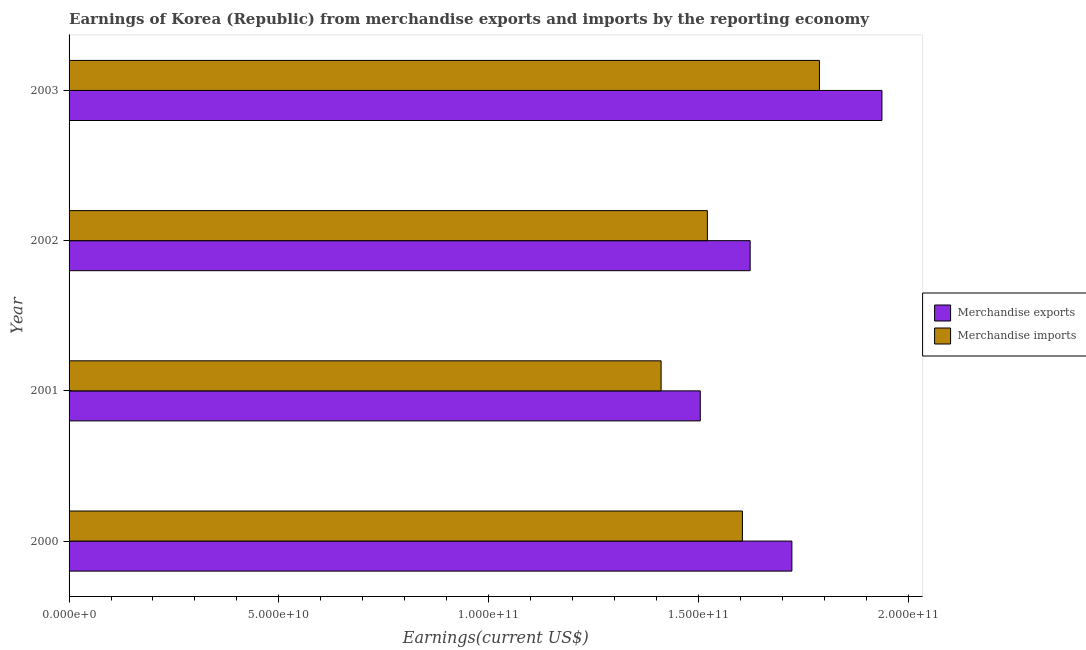How many groups of bars are there?
Offer a terse response. 4. Are the number of bars per tick equal to the number of legend labels?
Your answer should be compact. Yes. Are the number of bars on each tick of the Y-axis equal?
Your response must be concise. Yes. What is the earnings from merchandise imports in 2000?
Provide a succinct answer. 1.60e+11. Across all years, what is the maximum earnings from merchandise exports?
Give a very brief answer. 1.94e+11. Across all years, what is the minimum earnings from merchandise exports?
Your answer should be very brief. 1.50e+11. In which year was the earnings from merchandise imports maximum?
Offer a very short reply. 2003. What is the total earnings from merchandise imports in the graph?
Your answer should be compact. 6.33e+11. What is the difference between the earnings from merchandise imports in 2001 and that in 2003?
Keep it short and to the point. -3.77e+1. What is the difference between the earnings from merchandise exports in 2002 and the earnings from merchandise imports in 2001?
Offer a very short reply. 2.12e+1. What is the average earnings from merchandise exports per year?
Ensure brevity in your answer.  1.70e+11. In the year 2001, what is the difference between the earnings from merchandise imports and earnings from merchandise exports?
Ensure brevity in your answer.  -9.34e+09. What is the ratio of the earnings from merchandise exports in 2000 to that in 2001?
Provide a short and direct response. 1.15. What is the difference between the highest and the second highest earnings from merchandise exports?
Your answer should be very brief. 2.15e+1. What is the difference between the highest and the lowest earnings from merchandise imports?
Ensure brevity in your answer.  3.77e+1. In how many years, is the earnings from merchandise imports greater than the average earnings from merchandise imports taken over all years?
Give a very brief answer. 2. What does the 1st bar from the top in 2002 represents?
Offer a terse response. Merchandise imports. What does the 2nd bar from the bottom in 2002 represents?
Keep it short and to the point. Merchandise imports. Are all the bars in the graph horizontal?
Your answer should be compact. Yes. What is the difference between two consecutive major ticks on the X-axis?
Offer a terse response. 5.00e+1. Does the graph contain any zero values?
Keep it short and to the point. No. Does the graph contain grids?
Offer a very short reply. No. How are the legend labels stacked?
Ensure brevity in your answer.  Vertical. What is the title of the graph?
Make the answer very short. Earnings of Korea (Republic) from merchandise exports and imports by the reporting economy. Does "Secondary Education" appear as one of the legend labels in the graph?
Keep it short and to the point. No. What is the label or title of the X-axis?
Provide a succinct answer. Earnings(current US$). What is the Earnings(current US$) of Merchandise exports in 2000?
Keep it short and to the point. 1.72e+11. What is the Earnings(current US$) in Merchandise imports in 2000?
Give a very brief answer. 1.60e+11. What is the Earnings(current US$) of Merchandise exports in 2001?
Make the answer very short. 1.50e+11. What is the Earnings(current US$) in Merchandise imports in 2001?
Offer a very short reply. 1.41e+11. What is the Earnings(current US$) of Merchandise exports in 2002?
Your answer should be very brief. 1.62e+11. What is the Earnings(current US$) of Merchandise imports in 2002?
Your answer should be compact. 1.52e+11. What is the Earnings(current US$) in Merchandise exports in 2003?
Offer a very short reply. 1.94e+11. What is the Earnings(current US$) of Merchandise imports in 2003?
Provide a succinct answer. 1.79e+11. Across all years, what is the maximum Earnings(current US$) in Merchandise exports?
Keep it short and to the point. 1.94e+11. Across all years, what is the maximum Earnings(current US$) in Merchandise imports?
Provide a succinct answer. 1.79e+11. Across all years, what is the minimum Earnings(current US$) of Merchandise exports?
Your answer should be compact. 1.50e+11. Across all years, what is the minimum Earnings(current US$) in Merchandise imports?
Make the answer very short. 1.41e+11. What is the total Earnings(current US$) in Merchandise exports in the graph?
Your answer should be very brief. 6.79e+11. What is the total Earnings(current US$) of Merchandise imports in the graph?
Provide a short and direct response. 6.33e+11. What is the difference between the Earnings(current US$) in Merchandise exports in 2000 and that in 2001?
Your answer should be compact. 2.18e+1. What is the difference between the Earnings(current US$) of Merchandise imports in 2000 and that in 2001?
Provide a short and direct response. 1.94e+1. What is the difference between the Earnings(current US$) in Merchandise exports in 2000 and that in 2002?
Make the answer very short. 9.95e+09. What is the difference between the Earnings(current US$) of Merchandise imports in 2000 and that in 2002?
Offer a very short reply. 8.36e+09. What is the difference between the Earnings(current US$) in Merchandise exports in 2000 and that in 2003?
Make the answer very short. -2.15e+1. What is the difference between the Earnings(current US$) of Merchandise imports in 2000 and that in 2003?
Provide a short and direct response. -1.83e+1. What is the difference between the Earnings(current US$) of Merchandise exports in 2001 and that in 2002?
Your response must be concise. -1.19e+1. What is the difference between the Earnings(current US$) of Merchandise imports in 2001 and that in 2002?
Ensure brevity in your answer.  -1.10e+1. What is the difference between the Earnings(current US$) of Merchandise exports in 2001 and that in 2003?
Offer a very short reply. -4.33e+1. What is the difference between the Earnings(current US$) of Merchandise imports in 2001 and that in 2003?
Your answer should be compact. -3.77e+1. What is the difference between the Earnings(current US$) of Merchandise exports in 2002 and that in 2003?
Give a very brief answer. -3.14e+1. What is the difference between the Earnings(current US$) of Merchandise imports in 2002 and that in 2003?
Provide a succinct answer. -2.67e+1. What is the difference between the Earnings(current US$) of Merchandise exports in 2000 and the Earnings(current US$) of Merchandise imports in 2001?
Provide a short and direct response. 3.12e+1. What is the difference between the Earnings(current US$) of Merchandise exports in 2000 and the Earnings(current US$) of Merchandise imports in 2002?
Offer a terse response. 2.01e+1. What is the difference between the Earnings(current US$) in Merchandise exports in 2000 and the Earnings(current US$) in Merchandise imports in 2003?
Provide a succinct answer. -6.56e+09. What is the difference between the Earnings(current US$) in Merchandise exports in 2001 and the Earnings(current US$) in Merchandise imports in 2002?
Your answer should be compact. -1.69e+09. What is the difference between the Earnings(current US$) in Merchandise exports in 2001 and the Earnings(current US$) in Merchandise imports in 2003?
Make the answer very short. -2.84e+1. What is the difference between the Earnings(current US$) of Merchandise exports in 2002 and the Earnings(current US$) of Merchandise imports in 2003?
Provide a succinct answer. -1.65e+1. What is the average Earnings(current US$) in Merchandise exports per year?
Make the answer very short. 1.70e+11. What is the average Earnings(current US$) of Merchandise imports per year?
Your answer should be compact. 1.58e+11. In the year 2000, what is the difference between the Earnings(current US$) in Merchandise exports and Earnings(current US$) in Merchandise imports?
Offer a terse response. 1.18e+1. In the year 2001, what is the difference between the Earnings(current US$) of Merchandise exports and Earnings(current US$) of Merchandise imports?
Provide a short and direct response. 9.34e+09. In the year 2002, what is the difference between the Earnings(current US$) in Merchandise exports and Earnings(current US$) in Merchandise imports?
Offer a very short reply. 1.02e+1. In the year 2003, what is the difference between the Earnings(current US$) of Merchandise exports and Earnings(current US$) of Merchandise imports?
Give a very brief answer. 1.49e+1. What is the ratio of the Earnings(current US$) in Merchandise exports in 2000 to that in 2001?
Offer a terse response. 1.15. What is the ratio of the Earnings(current US$) in Merchandise imports in 2000 to that in 2001?
Provide a short and direct response. 1.14. What is the ratio of the Earnings(current US$) of Merchandise exports in 2000 to that in 2002?
Offer a terse response. 1.06. What is the ratio of the Earnings(current US$) of Merchandise imports in 2000 to that in 2002?
Your answer should be very brief. 1.05. What is the ratio of the Earnings(current US$) of Merchandise exports in 2000 to that in 2003?
Your response must be concise. 0.89. What is the ratio of the Earnings(current US$) of Merchandise imports in 2000 to that in 2003?
Give a very brief answer. 0.9. What is the ratio of the Earnings(current US$) in Merchandise exports in 2001 to that in 2002?
Keep it short and to the point. 0.93. What is the ratio of the Earnings(current US$) of Merchandise imports in 2001 to that in 2002?
Your answer should be compact. 0.93. What is the ratio of the Earnings(current US$) of Merchandise exports in 2001 to that in 2003?
Give a very brief answer. 0.78. What is the ratio of the Earnings(current US$) in Merchandise imports in 2001 to that in 2003?
Provide a short and direct response. 0.79. What is the ratio of the Earnings(current US$) in Merchandise exports in 2002 to that in 2003?
Ensure brevity in your answer.  0.84. What is the ratio of the Earnings(current US$) of Merchandise imports in 2002 to that in 2003?
Make the answer very short. 0.85. What is the difference between the highest and the second highest Earnings(current US$) of Merchandise exports?
Offer a terse response. 2.15e+1. What is the difference between the highest and the second highest Earnings(current US$) in Merchandise imports?
Offer a very short reply. 1.83e+1. What is the difference between the highest and the lowest Earnings(current US$) in Merchandise exports?
Give a very brief answer. 4.33e+1. What is the difference between the highest and the lowest Earnings(current US$) in Merchandise imports?
Give a very brief answer. 3.77e+1. 